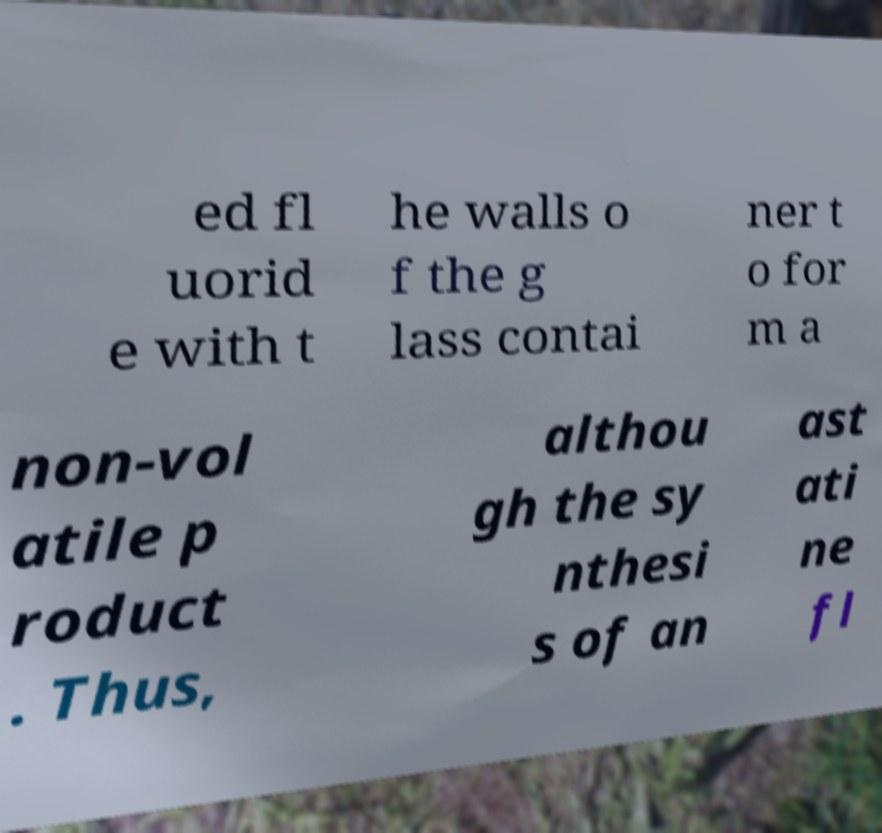There's text embedded in this image that I need extracted. Can you transcribe it verbatim? ed fl uorid e with t he walls o f the g lass contai ner t o for m a non-vol atile p roduct . Thus, althou gh the sy nthesi s of an ast ati ne fl 